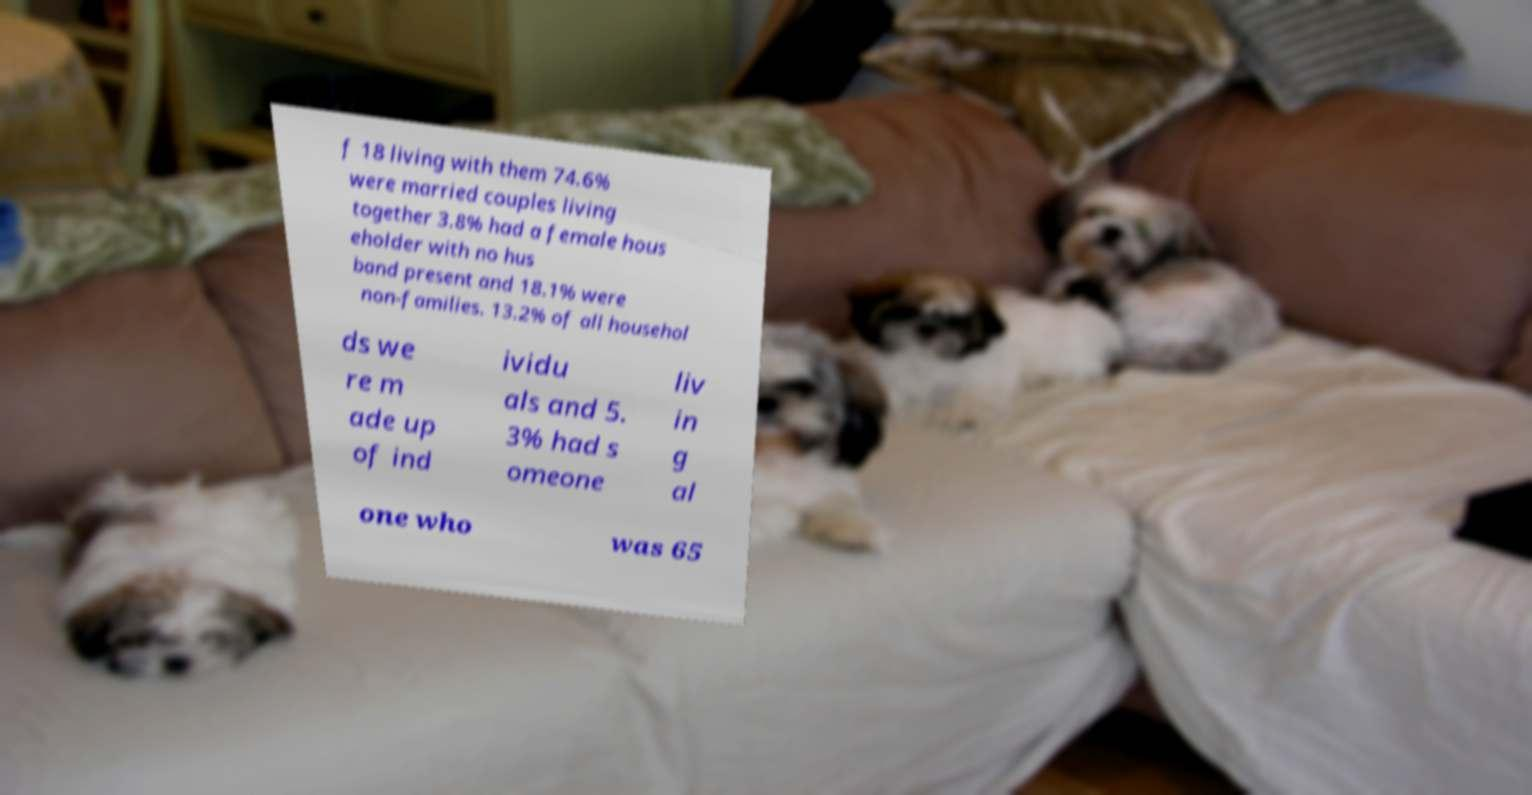Can you read and provide the text displayed in the image?This photo seems to have some interesting text. Can you extract and type it out for me? f 18 living with them 74.6% were married couples living together 3.8% had a female hous eholder with no hus band present and 18.1% were non-families. 13.2% of all househol ds we re m ade up of ind ividu als and 5. 3% had s omeone liv in g al one who was 65 